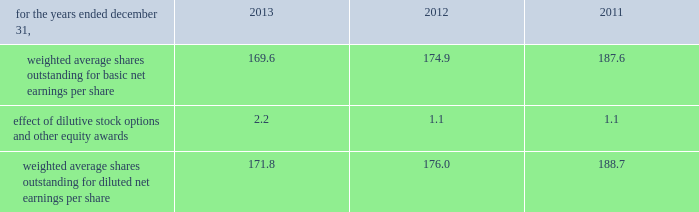Zimmer holdings , inc .
2013 form 10-k annual report notes to consolidated financial statements ( continued ) state income tax returns are generally subject to examination for a period of 3 to 5 years after filing of the respective return .
The state impact of any federal changes generally remains subject to examination by various states for a period of up to one year after formal notification to the states .
We have various state income tax returns in the process of examination , administrative appeals or litigation .
Our tax returns are currently under examination in various foreign jurisdictions .
Foreign jurisdictions have statutes of limitations generally ranging from 3 to 5 years .
Years still open to examination by foreign tax authorities in major jurisdictions include : australia ( 2009 onward ) , canada ( 2007 onward ) , france ( 2011 onward ) , germany ( 2009 onward ) , ireland ( 2009 onward ) , italy ( 2010 onward ) , japan ( 2010 onward ) , korea ( 2008 onward ) , puerto rico ( 2008 onward ) , switzerland ( 2012 onward ) , and the united kingdom ( 2012 onward ) .
16 .
Capital stock and earnings per share we are authorized to issue 250 million shares of preferred stock , none of which were issued or outstanding as of december 31 , 2013 .
The numerator for both basic and diluted earnings per share is net earnings available to common stockholders .
The denominator for basic earnings per share is the weighted average number of common shares outstanding during the period .
The denominator for diluted earnings per share is weighted average shares outstanding adjusted for the effect of dilutive stock options and other equity awards .
The following is a reconciliation of weighted average shares for the basic and diluted share computations ( in millions ) : .
Weighted average shares outstanding for basic net earnings per share 169.6 174.9 187.6 effect of dilutive stock options and other equity awards 2.2 1.1 1.1 weighted average shares outstanding for diluted net earnings per share 171.8 176.0 188.7 for the year ended december 31 , 2013 , an average of 3.1 million options to purchase shares of common stock were not included in the computation of diluted earnings per share as the exercise prices of these options were greater than the average market price of the common stock .
For the years ended december 31 , 2012 and 2011 , an average of 11.9 million and 13.2 million options , respectively , were not included .
During 2013 , we repurchased 9.1 million shares of our common stock at an average price of $ 78.88 per share for a total cash outlay of $ 719.0 million , including commissions .
Effective january 1 , 2014 , we have a new share repurchase program that authorizes purchases of up to $ 1.0 billion with no expiration date .
No further purchases will be made under the previous share repurchase program .
17 .
Segment data we design , develop , manufacture and market orthopaedic reconstructive implants , biologics , dental implants , spinal implants , trauma products and related surgical products which include surgical supplies and instruments designed to aid in surgical procedures and post-operation rehabilitation .
We also provide other healthcare-related services .
We manage operations through three major geographic segments 2013 the americas , which is comprised principally of the u.s .
And includes other north , central and south american markets ; europe , which is comprised principally of europe and includes the middle east and african markets ; and asia pacific , which is comprised primarily of japan and includes other asian and pacific markets .
This structure is the basis for our reportable segment information discussed below .
Management evaluates reportable segment performance based upon segment operating profit exclusive of operating expenses pertaining to share-based payment expense , inventory step-up and certain other inventory and manufacturing related charges , 201ccertain claims , 201d goodwill impairment , 201cspecial items , 201d and global operations and corporate functions .
Global operations and corporate functions include research , development engineering , medical education , brand management , corporate legal , finance , and human resource functions , u.s. , puerto rico and ireland-based manufacturing operations and logistics and intangible asset amortization resulting from business combination accounting .
Intercompany transactions have been eliminated from segment operating profit .
Management reviews accounts receivable , inventory , property , plant and equipment , goodwill and intangible assets by reportable segment exclusive of u.s. , puerto rico and ireland-based manufacturing operations and logistics and corporate assets. .
What was the change in millions of weighted average shares outstanding for diluted net earnings per share between 2011 and 2012? 
Computations: (176.0 - 188.7)
Answer: -12.7. 